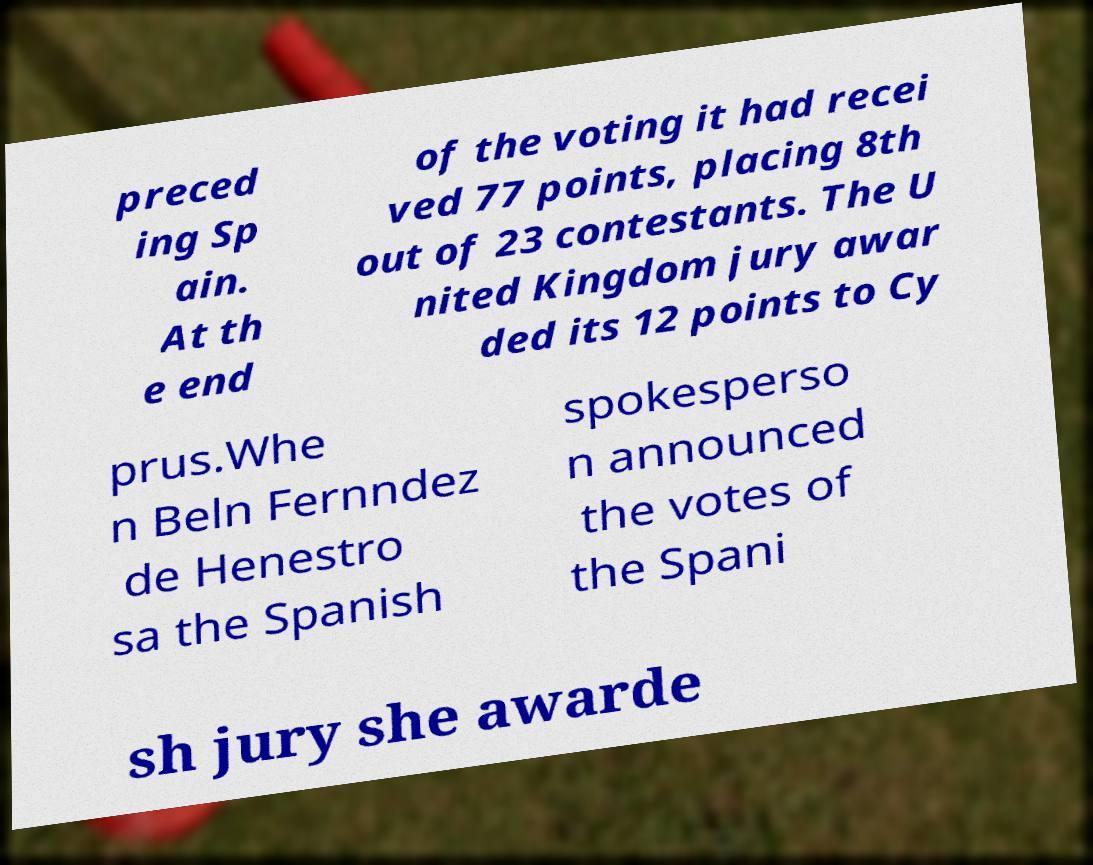What messages or text are displayed in this image? I need them in a readable, typed format. preced ing Sp ain. At th e end of the voting it had recei ved 77 points, placing 8th out of 23 contestants. The U nited Kingdom jury awar ded its 12 points to Cy prus.Whe n Beln Fernndez de Henestro sa the Spanish spokesperso n announced the votes of the Spani sh jury she awarde 